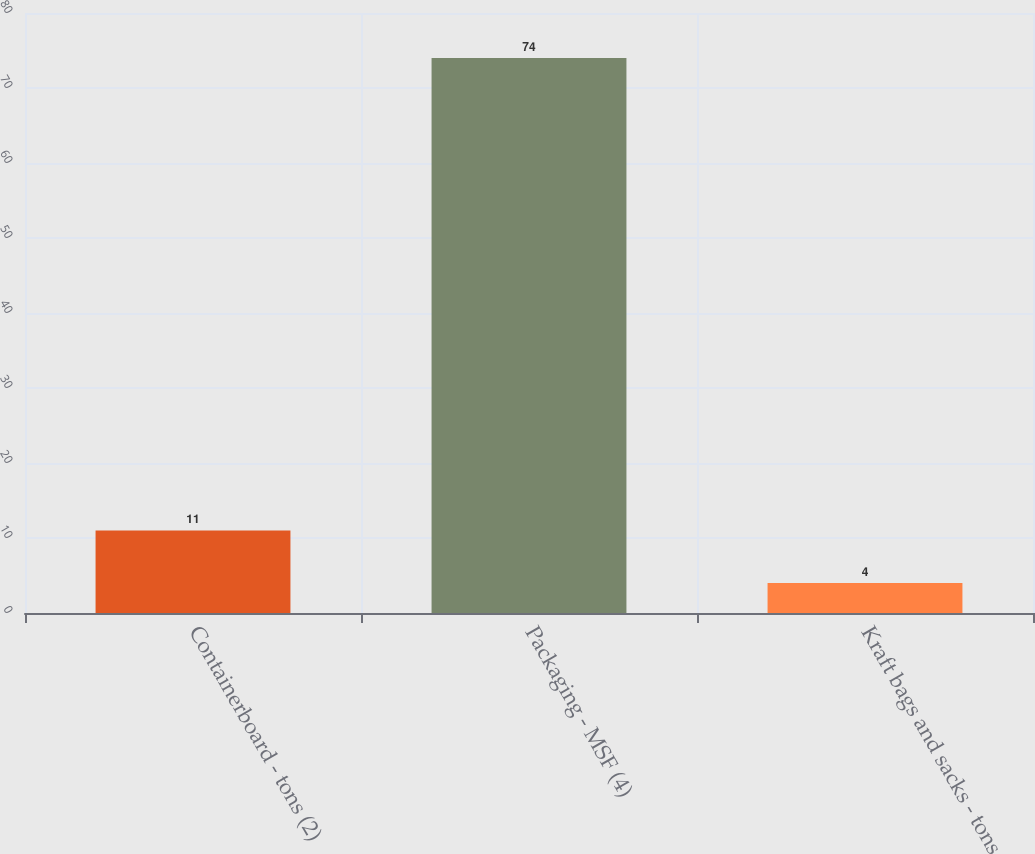<chart> <loc_0><loc_0><loc_500><loc_500><bar_chart><fcel>Containerboard - tons (2)<fcel>Packaging - MSF (4)<fcel>Kraft bags and sacks - tons<nl><fcel>11<fcel>74<fcel>4<nl></chart> 